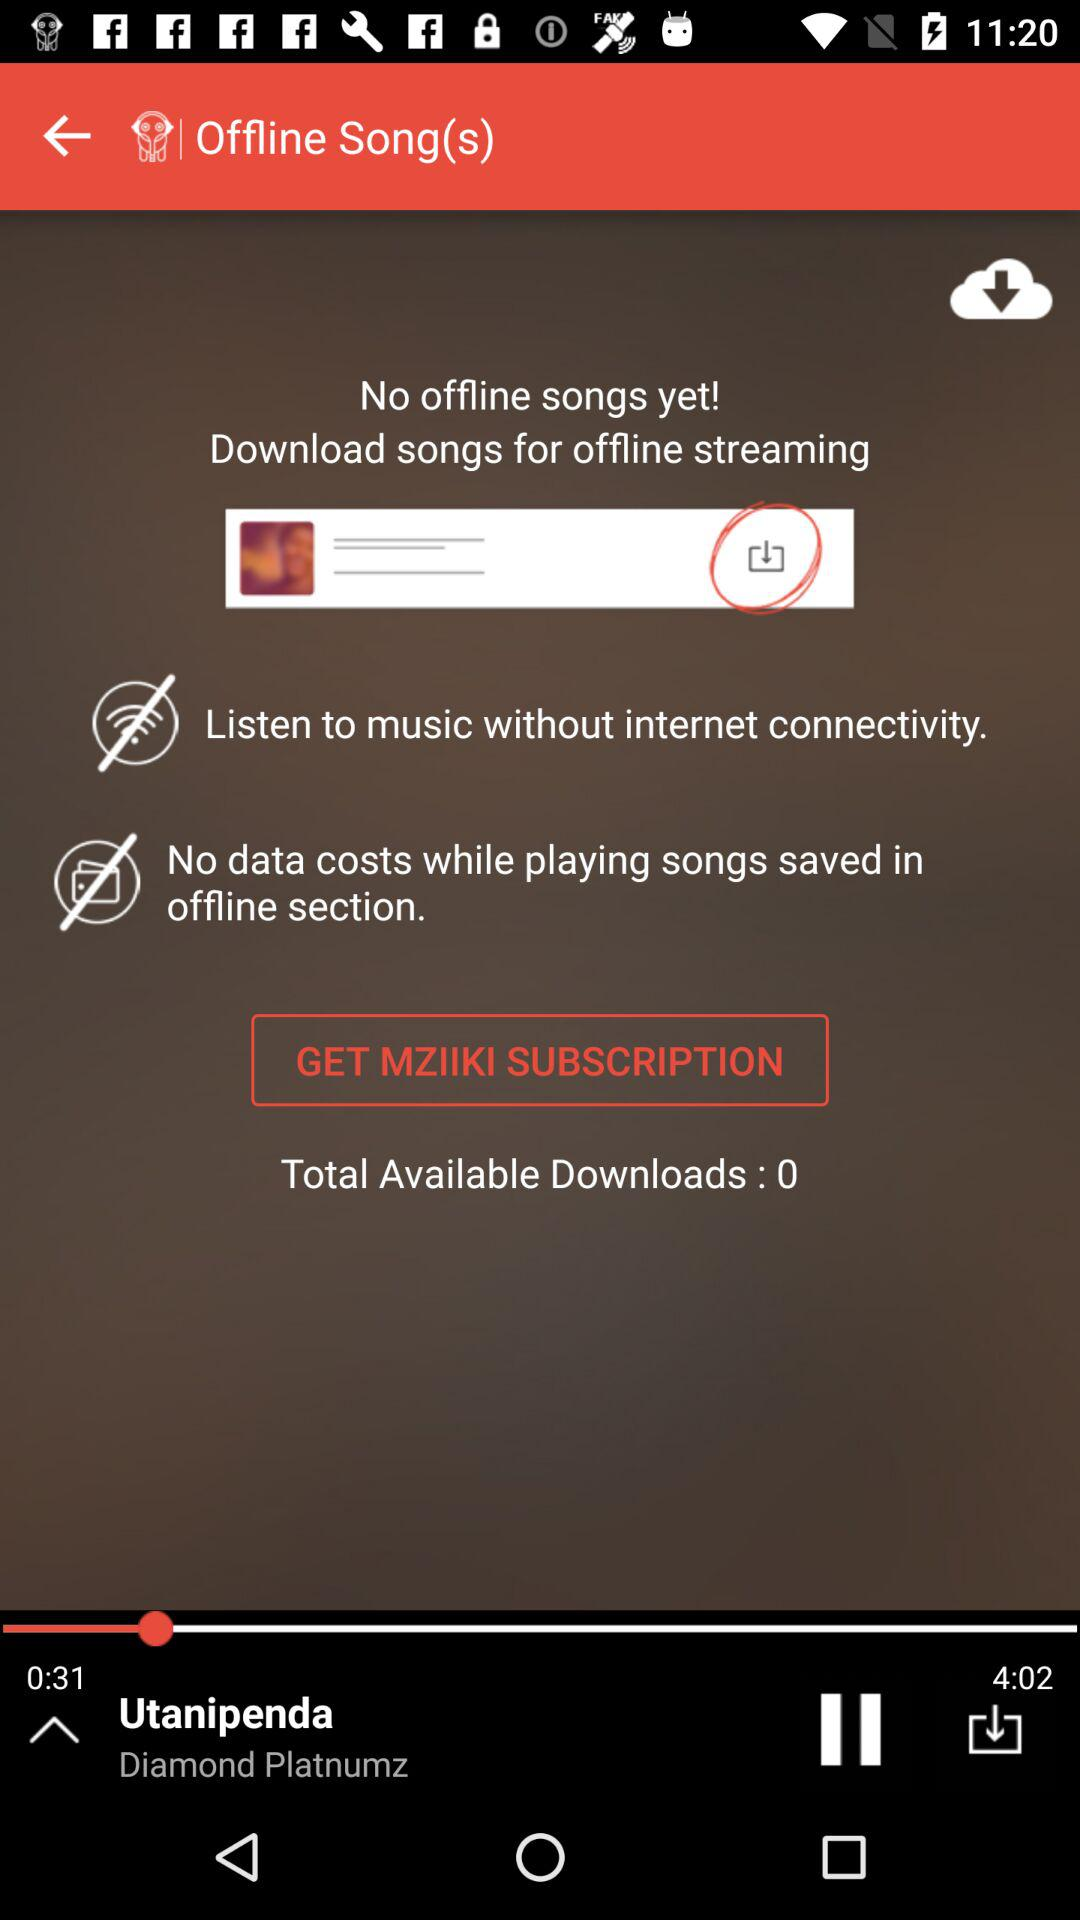How much of the song has been finished playing? The part of the song that is finished playing is 0:31. 